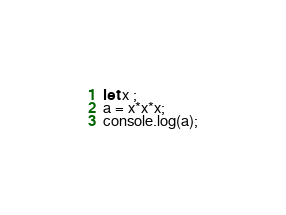Convert code to text. <code><loc_0><loc_0><loc_500><loc_500><_JavaScript_>let x ;
a = x*x*x;
console.log(a);
</code> 